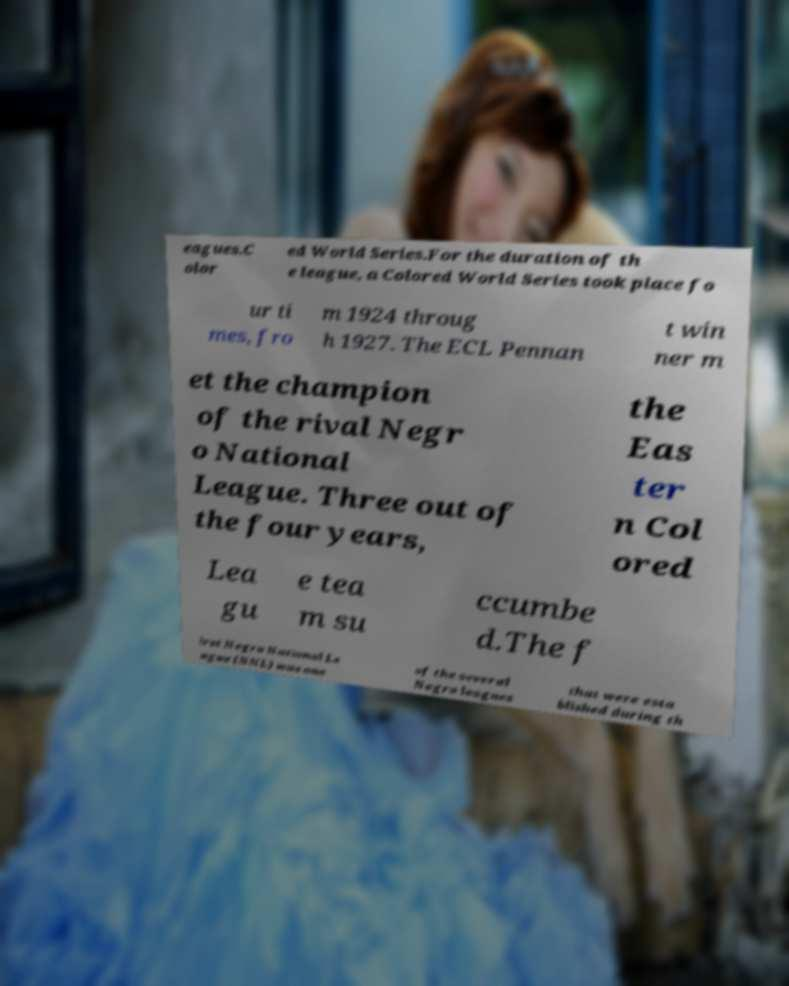What messages or text are displayed in this image? I need them in a readable, typed format. eagues.C olor ed World Series.For the duration of th e league, a Colored World Series took place fo ur ti mes, fro m 1924 throug h 1927. The ECL Pennan t win ner m et the champion of the rival Negr o National League. Three out of the four years, the Eas ter n Col ored Lea gu e tea m su ccumbe d.The f irst Negro National Le ague (NNL) was one of the several Negro leagues that were esta blished during th 